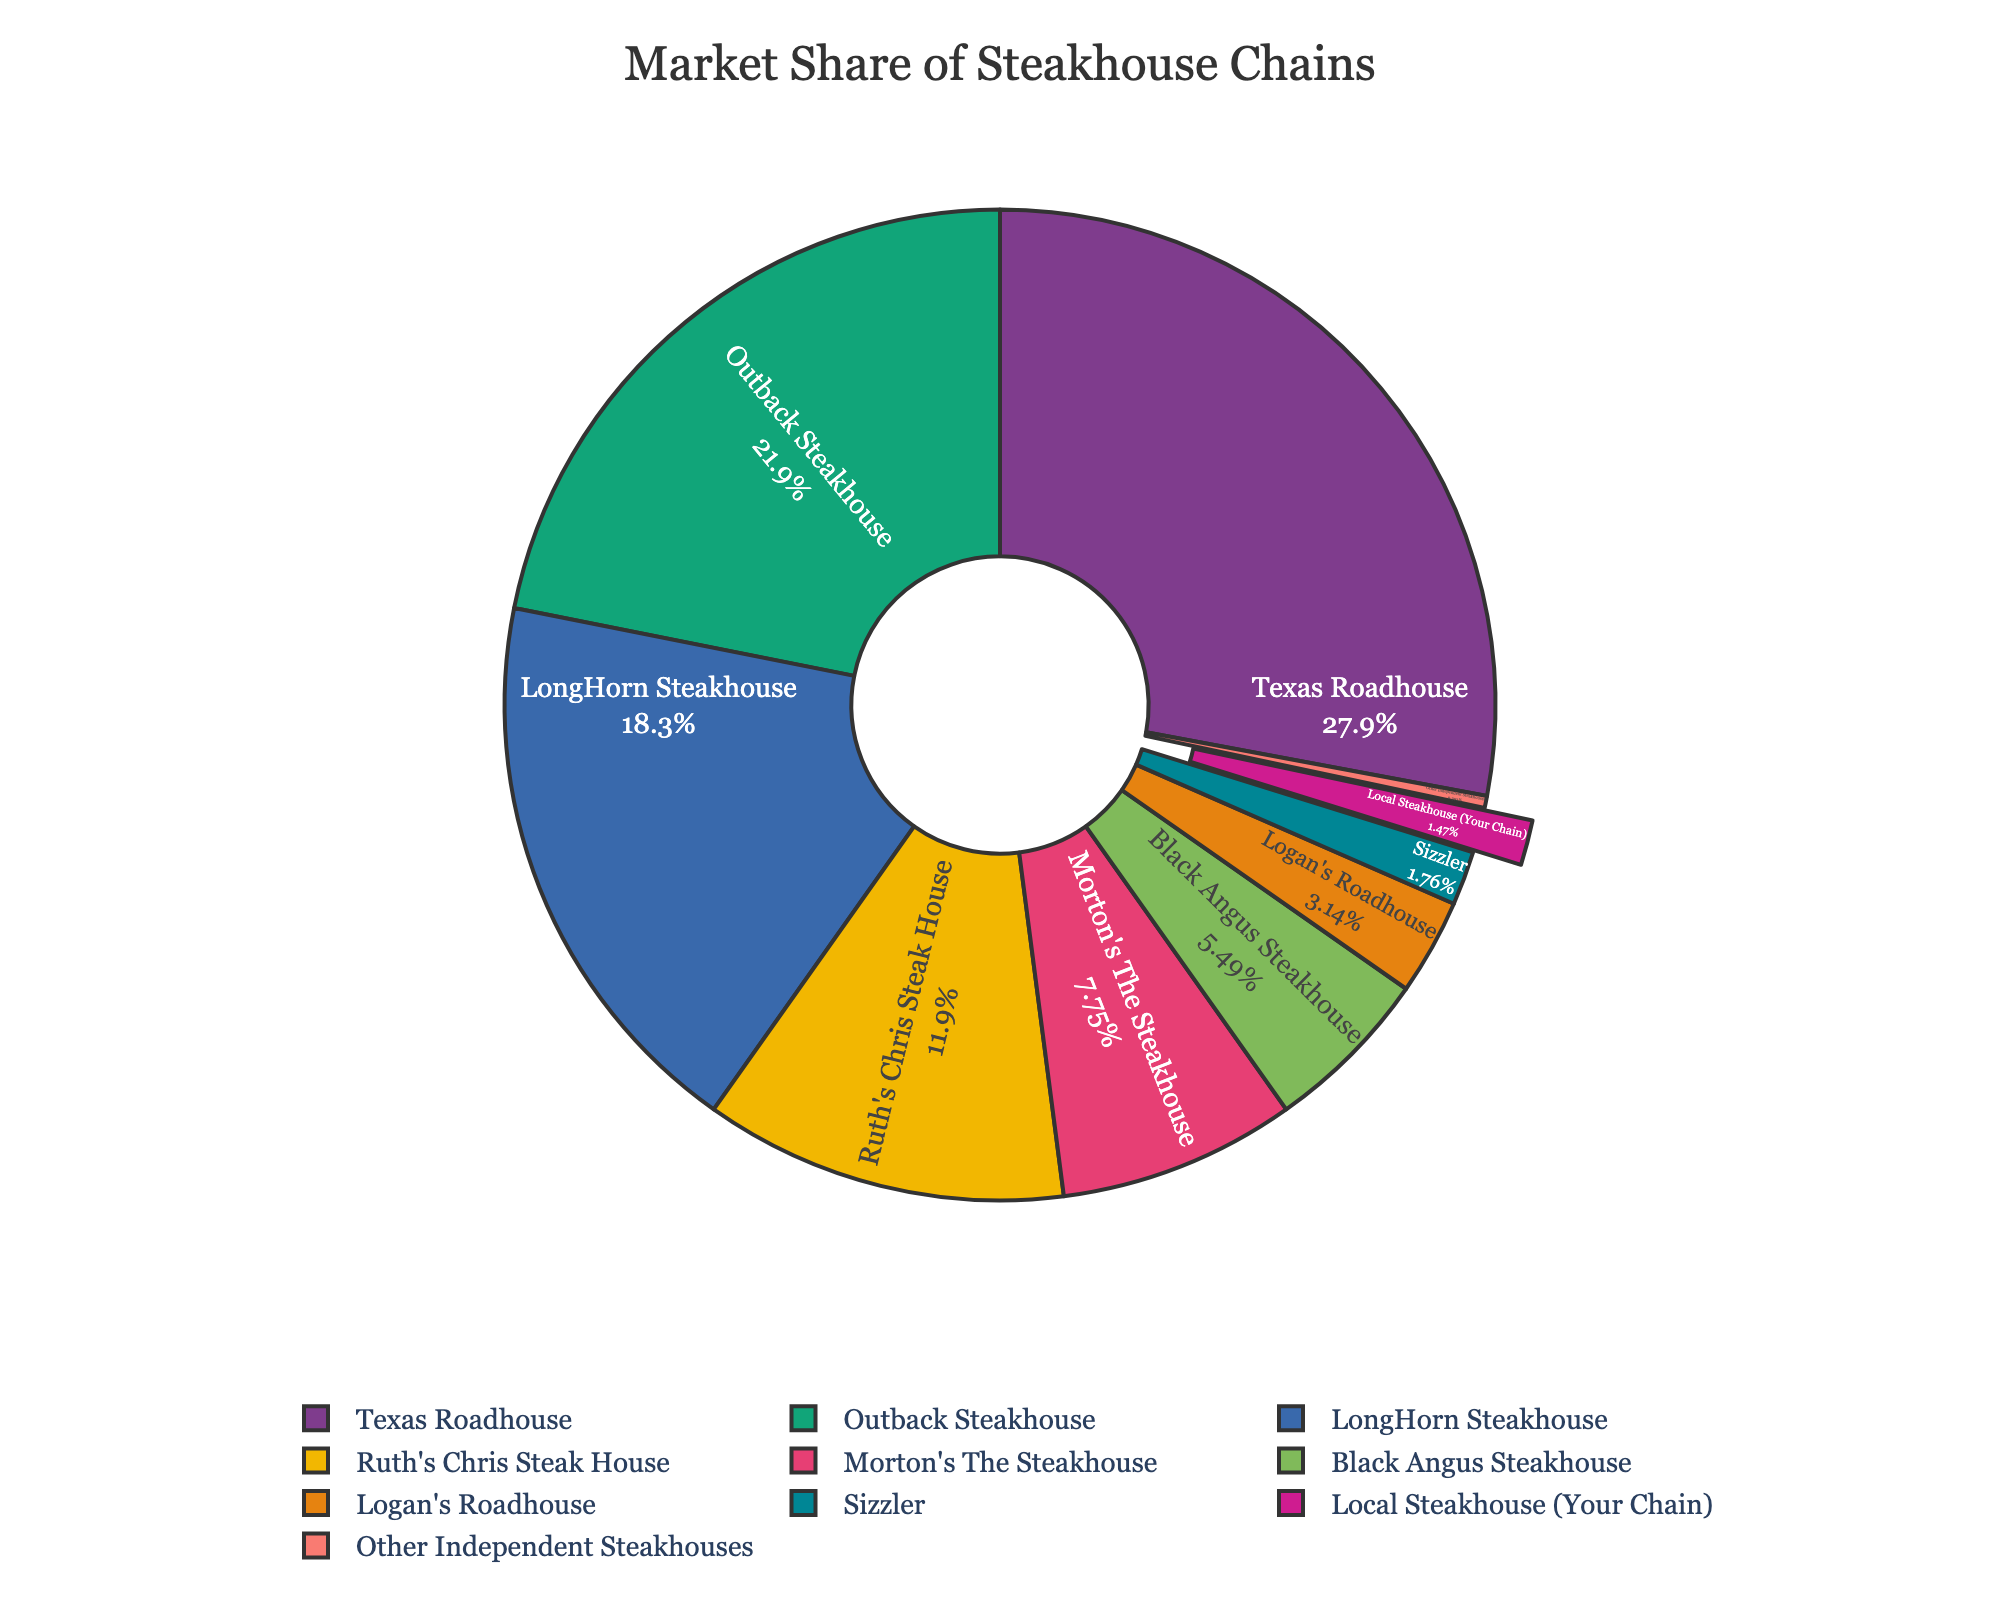Who has the highest market share among the steakhouse chains? By observing the pie chart, the steakhouse chain with the largest segment size represents the highest market share. The segment for Texas Roadhouse is the largest.
Answer: Texas Roadhouse Which steakhouse chains have a market share greater than 20%? We look for the segments that represent more than one-fifth of the whole. The segments for Texas Roadhouse and Outback Steakhouse exceed 20%.
Answer: Texas Roadhouse, Outback Steakhouse How much larger is Texas Roadhouse's market share compared to LongHorn Steakhouse? Texas Roadhouse has 28.5%, and LongHorn Steakhouse has 18.7%. The difference is found by subtracting LongHorn's share from Texas Roadhouse's: 28.5% - 18.7% = 9.8%.
Answer: 9.8% What is the total market share of the top three steakhouse chains? The top three chains are Texas Roadhouse (28.5%), Outback Steakhouse (22.3%), and LongHorn Steakhouse (18.7%). Adding these together: 28.5% + 22.3% + 18.7% = 69.5%.
Answer: 69.5% How does the market share of your local steakhouse compare to Sizzler? Your local steakhouse has 1.5%, and Sizzler has 1.8%. Your local steakhouse's market share is 0.3% less than Sizzler’s (1.8% - 1.5% = 0.3%).
Answer: 0.3% less Which steakhouse chain has the smallest market share, excluding Other Independent Steakhouses? From the segments, excluding Other Independent Steakhouses, the smallest segment is for your local steakhouse: Local Steakhouse (Your Chain) with 1.5%.
Answer: Local Steakhouse (Your Chain) What is the combined market share of Morton's The Steakhouse and Black Angus Steakhouse? Morton's The Steakhouse has 7.9%, and Black Angus Steakhouse has 5.6%. Adding these together: 7.9% + 5.6% = 13.5%.
Answer: 13.5% What color represents Logan's Roadhouse in the pie chart? By observing the segment color for Logan's Roadhouse, we can identify it. The pie chart should indicate Logan's Roadhouse with a distinct color.
Answer: Depends on chart What percentage of the market share is held by steakhouses outside the top 5 chains? The market shares for Texas Roadhouse, Outback Steakhouse, LongHorn Steakhouse, Ruth's Chris Steak House, and Morton's The Steakhouse must be summed, then subtracted from 100%. Sum: 28.5% + 22.3% + 18.7% + 12.1% + 7.9% = 89.5%. The remaining share is 100% - 89.5% = 10.5%.
Answer: 10.5% What is the difference in market share between Ruth's Chris Steak House and Logan's Roadhouse? Ruth's Chris Steak House has 12.1%, and Logan's Roadhouse has 3.2%. The difference is found by subtracting Logan's share from Ruth's: 12.1% - 3.2% = 8.9%.
Answer: 8.9% 